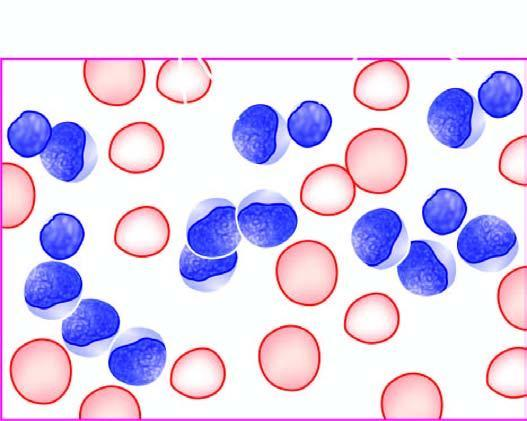re the cells large, with round to convoluted nuclei having high n/c ratio and no cytoplasmic granularity?
Answer the question using a single word or phrase. Yes 